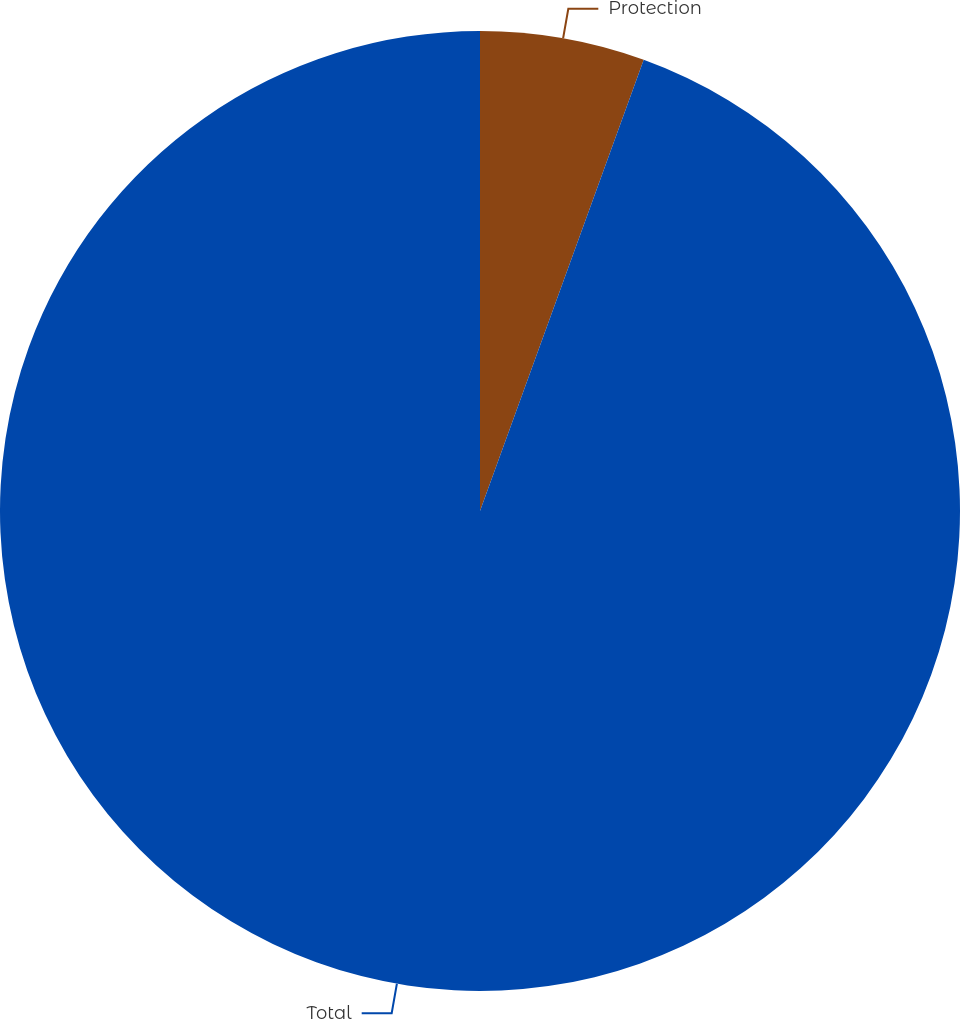Convert chart to OTSL. <chart><loc_0><loc_0><loc_500><loc_500><pie_chart><fcel>Protection<fcel>Total<nl><fcel>5.54%<fcel>94.46%<nl></chart> 